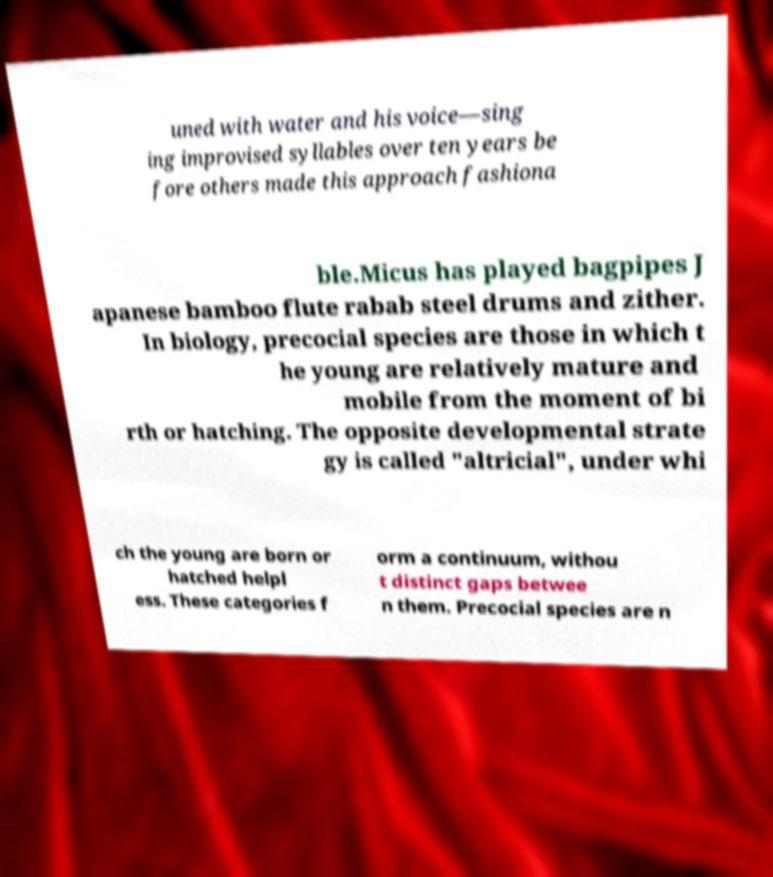There's text embedded in this image that I need extracted. Can you transcribe it verbatim? uned with water and his voice—sing ing improvised syllables over ten years be fore others made this approach fashiona ble.Micus has played bagpipes J apanese bamboo flute rabab steel drums and zither. In biology, precocial species are those in which t he young are relatively mature and mobile from the moment of bi rth or hatching. The opposite developmental strate gy is called "altricial", under whi ch the young are born or hatched helpl ess. These categories f orm a continuum, withou t distinct gaps betwee n them. Precocial species are n 